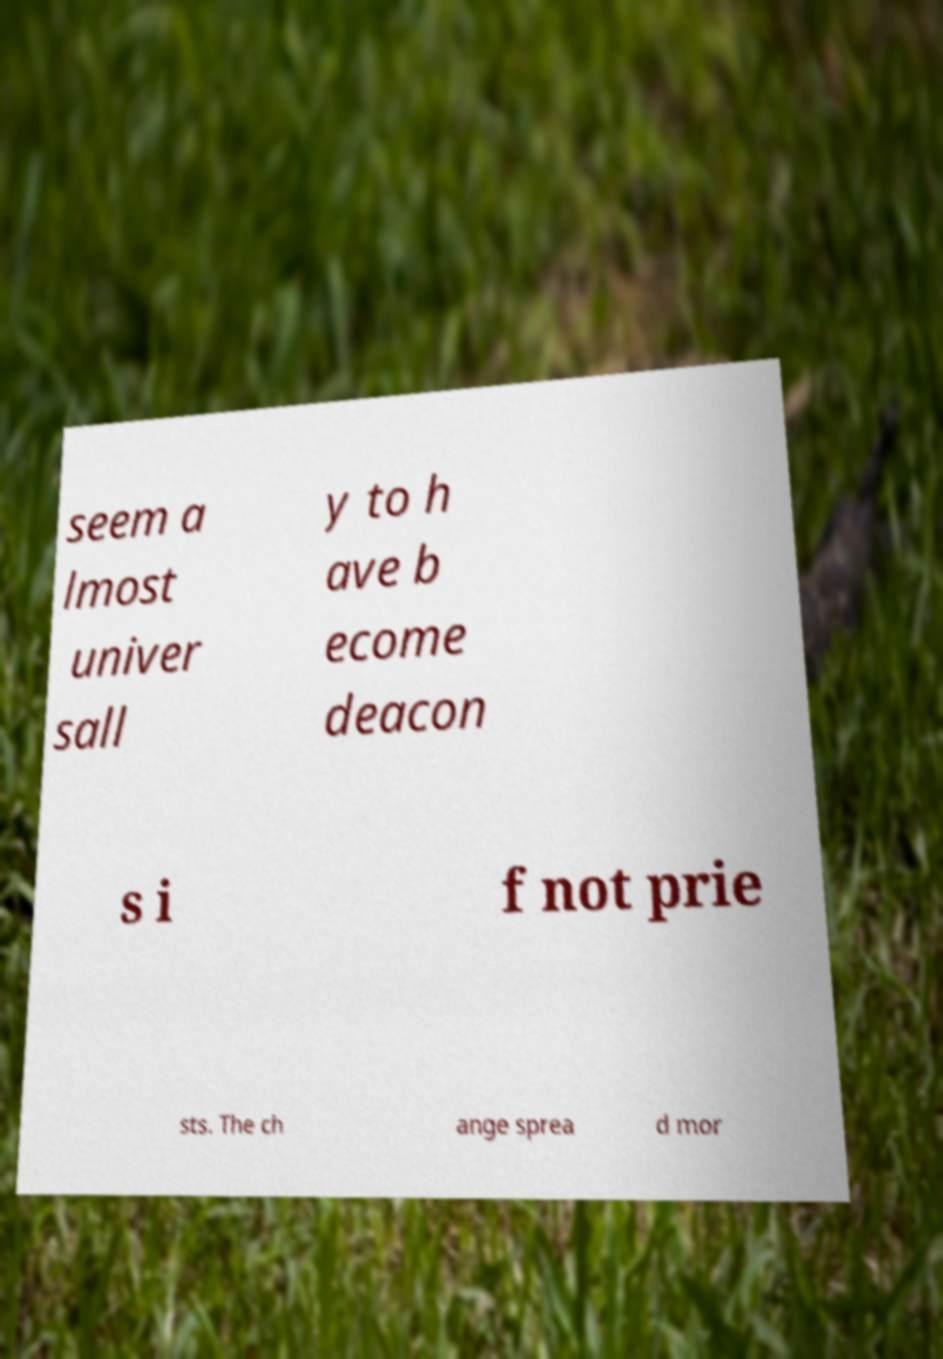Can you read and provide the text displayed in the image?This photo seems to have some interesting text. Can you extract and type it out for me? seem a lmost univer sall y to h ave b ecome deacon s i f not prie sts. The ch ange sprea d mor 